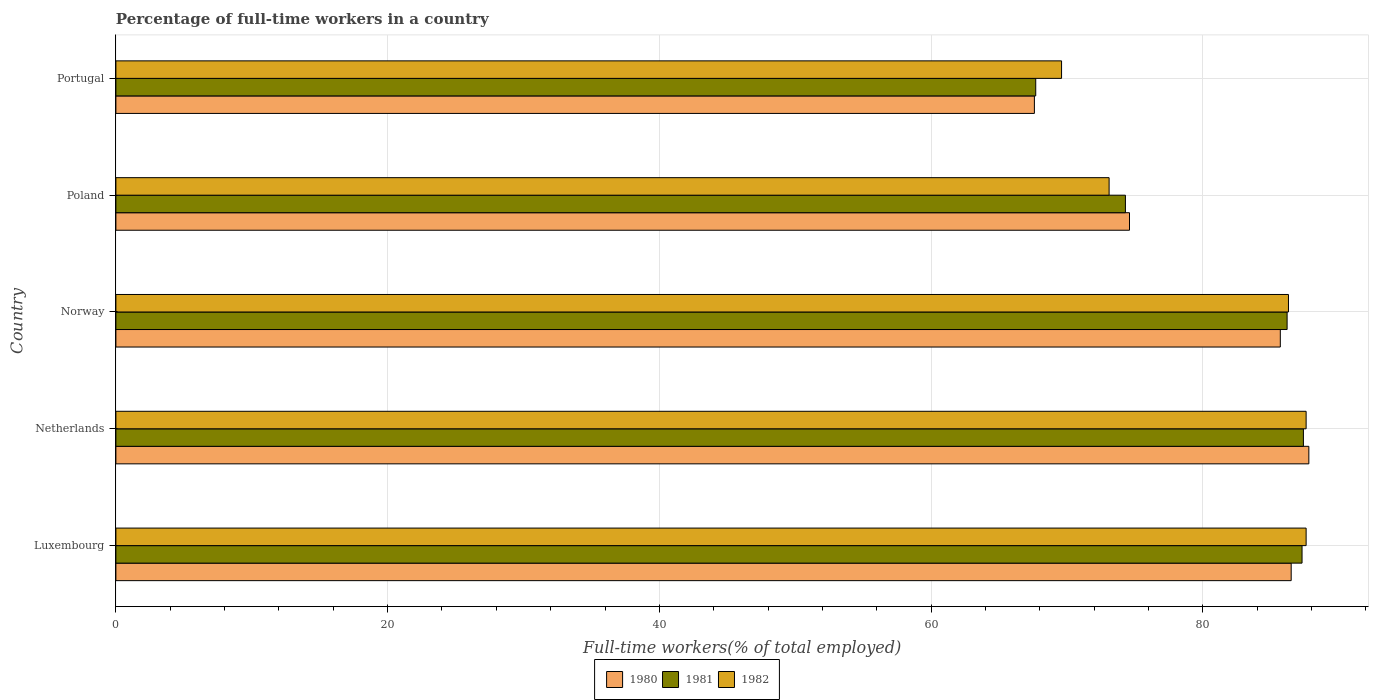Are the number of bars per tick equal to the number of legend labels?
Provide a succinct answer. Yes. Are the number of bars on each tick of the Y-axis equal?
Make the answer very short. Yes. What is the label of the 2nd group of bars from the top?
Offer a terse response. Poland. In how many cases, is the number of bars for a given country not equal to the number of legend labels?
Keep it short and to the point. 0. What is the percentage of full-time workers in 1980 in Netherlands?
Make the answer very short. 87.8. Across all countries, what is the maximum percentage of full-time workers in 1982?
Give a very brief answer. 87.6. Across all countries, what is the minimum percentage of full-time workers in 1980?
Make the answer very short. 67.6. In which country was the percentage of full-time workers in 1980 minimum?
Give a very brief answer. Portugal. What is the total percentage of full-time workers in 1980 in the graph?
Make the answer very short. 402.2. What is the difference between the percentage of full-time workers in 1981 in Poland and the percentage of full-time workers in 1980 in Portugal?
Provide a short and direct response. 6.7. What is the average percentage of full-time workers in 1980 per country?
Offer a very short reply. 80.44. What is the difference between the percentage of full-time workers in 1981 and percentage of full-time workers in 1980 in Poland?
Your answer should be very brief. -0.3. In how many countries, is the percentage of full-time workers in 1980 greater than 4 %?
Keep it short and to the point. 5. What is the ratio of the percentage of full-time workers in 1982 in Luxembourg to that in Poland?
Give a very brief answer. 1.2. Is the percentage of full-time workers in 1980 in Poland less than that in Portugal?
Provide a short and direct response. No. Is the difference between the percentage of full-time workers in 1981 in Poland and Portugal greater than the difference between the percentage of full-time workers in 1980 in Poland and Portugal?
Make the answer very short. No. What is the difference between the highest and the second highest percentage of full-time workers in 1980?
Ensure brevity in your answer.  1.3. What does the 2nd bar from the top in Luxembourg represents?
Your answer should be compact. 1981. Is it the case that in every country, the sum of the percentage of full-time workers in 1982 and percentage of full-time workers in 1980 is greater than the percentage of full-time workers in 1981?
Keep it short and to the point. Yes. Are the values on the major ticks of X-axis written in scientific E-notation?
Provide a short and direct response. No. How many legend labels are there?
Your response must be concise. 3. How are the legend labels stacked?
Ensure brevity in your answer.  Horizontal. What is the title of the graph?
Provide a succinct answer. Percentage of full-time workers in a country. Does "2008" appear as one of the legend labels in the graph?
Your answer should be compact. No. What is the label or title of the X-axis?
Give a very brief answer. Full-time workers(% of total employed). What is the label or title of the Y-axis?
Provide a short and direct response. Country. What is the Full-time workers(% of total employed) of 1980 in Luxembourg?
Ensure brevity in your answer.  86.5. What is the Full-time workers(% of total employed) of 1981 in Luxembourg?
Provide a short and direct response. 87.3. What is the Full-time workers(% of total employed) in 1982 in Luxembourg?
Keep it short and to the point. 87.6. What is the Full-time workers(% of total employed) in 1980 in Netherlands?
Offer a terse response. 87.8. What is the Full-time workers(% of total employed) of 1981 in Netherlands?
Ensure brevity in your answer.  87.4. What is the Full-time workers(% of total employed) in 1982 in Netherlands?
Make the answer very short. 87.6. What is the Full-time workers(% of total employed) of 1980 in Norway?
Give a very brief answer. 85.7. What is the Full-time workers(% of total employed) of 1981 in Norway?
Your response must be concise. 86.2. What is the Full-time workers(% of total employed) of 1982 in Norway?
Make the answer very short. 86.3. What is the Full-time workers(% of total employed) of 1980 in Poland?
Keep it short and to the point. 74.6. What is the Full-time workers(% of total employed) of 1981 in Poland?
Keep it short and to the point. 74.3. What is the Full-time workers(% of total employed) in 1982 in Poland?
Make the answer very short. 73.1. What is the Full-time workers(% of total employed) in 1980 in Portugal?
Your answer should be very brief. 67.6. What is the Full-time workers(% of total employed) of 1981 in Portugal?
Give a very brief answer. 67.7. What is the Full-time workers(% of total employed) in 1982 in Portugal?
Keep it short and to the point. 69.6. Across all countries, what is the maximum Full-time workers(% of total employed) in 1980?
Your answer should be very brief. 87.8. Across all countries, what is the maximum Full-time workers(% of total employed) in 1981?
Make the answer very short. 87.4. Across all countries, what is the maximum Full-time workers(% of total employed) in 1982?
Keep it short and to the point. 87.6. Across all countries, what is the minimum Full-time workers(% of total employed) in 1980?
Offer a very short reply. 67.6. Across all countries, what is the minimum Full-time workers(% of total employed) of 1981?
Offer a very short reply. 67.7. Across all countries, what is the minimum Full-time workers(% of total employed) of 1982?
Ensure brevity in your answer.  69.6. What is the total Full-time workers(% of total employed) in 1980 in the graph?
Provide a succinct answer. 402.2. What is the total Full-time workers(% of total employed) in 1981 in the graph?
Provide a short and direct response. 402.9. What is the total Full-time workers(% of total employed) in 1982 in the graph?
Provide a succinct answer. 404.2. What is the difference between the Full-time workers(% of total employed) of 1980 in Luxembourg and that in Netherlands?
Offer a very short reply. -1.3. What is the difference between the Full-time workers(% of total employed) in 1980 in Luxembourg and that in Norway?
Offer a very short reply. 0.8. What is the difference between the Full-time workers(% of total employed) in 1981 in Luxembourg and that in Norway?
Keep it short and to the point. 1.1. What is the difference between the Full-time workers(% of total employed) of 1980 in Luxembourg and that in Poland?
Your answer should be very brief. 11.9. What is the difference between the Full-time workers(% of total employed) of 1981 in Luxembourg and that in Poland?
Your answer should be very brief. 13. What is the difference between the Full-time workers(% of total employed) of 1981 in Luxembourg and that in Portugal?
Make the answer very short. 19.6. What is the difference between the Full-time workers(% of total employed) in 1980 in Netherlands and that in Norway?
Provide a short and direct response. 2.1. What is the difference between the Full-time workers(% of total employed) in 1982 in Netherlands and that in Norway?
Keep it short and to the point. 1.3. What is the difference between the Full-time workers(% of total employed) of 1980 in Netherlands and that in Portugal?
Ensure brevity in your answer.  20.2. What is the difference between the Full-time workers(% of total employed) of 1981 in Netherlands and that in Portugal?
Provide a succinct answer. 19.7. What is the difference between the Full-time workers(% of total employed) of 1980 in Norway and that in Poland?
Give a very brief answer. 11.1. What is the difference between the Full-time workers(% of total employed) in 1982 in Norway and that in Poland?
Offer a very short reply. 13.2. What is the difference between the Full-time workers(% of total employed) of 1981 in Norway and that in Portugal?
Ensure brevity in your answer.  18.5. What is the difference between the Full-time workers(% of total employed) in 1982 in Norway and that in Portugal?
Ensure brevity in your answer.  16.7. What is the difference between the Full-time workers(% of total employed) of 1981 in Poland and that in Portugal?
Give a very brief answer. 6.6. What is the difference between the Full-time workers(% of total employed) in 1982 in Poland and that in Portugal?
Offer a very short reply. 3.5. What is the difference between the Full-time workers(% of total employed) in 1980 in Luxembourg and the Full-time workers(% of total employed) in 1981 in Netherlands?
Offer a terse response. -0.9. What is the difference between the Full-time workers(% of total employed) in 1980 in Luxembourg and the Full-time workers(% of total employed) in 1982 in Netherlands?
Give a very brief answer. -1.1. What is the difference between the Full-time workers(% of total employed) of 1980 in Luxembourg and the Full-time workers(% of total employed) of 1982 in Norway?
Offer a terse response. 0.2. What is the difference between the Full-time workers(% of total employed) in 1980 in Luxembourg and the Full-time workers(% of total employed) in 1981 in Poland?
Provide a short and direct response. 12.2. What is the difference between the Full-time workers(% of total employed) in 1980 in Netherlands and the Full-time workers(% of total employed) in 1981 in Norway?
Offer a very short reply. 1.6. What is the difference between the Full-time workers(% of total employed) of 1981 in Netherlands and the Full-time workers(% of total employed) of 1982 in Norway?
Your answer should be compact. 1.1. What is the difference between the Full-time workers(% of total employed) in 1980 in Netherlands and the Full-time workers(% of total employed) in 1981 in Portugal?
Keep it short and to the point. 20.1. What is the difference between the Full-time workers(% of total employed) in 1980 in Norway and the Full-time workers(% of total employed) in 1981 in Poland?
Your answer should be compact. 11.4. What is the difference between the Full-time workers(% of total employed) in 1980 in Norway and the Full-time workers(% of total employed) in 1982 in Poland?
Provide a succinct answer. 12.6. What is the difference between the Full-time workers(% of total employed) in 1981 in Norway and the Full-time workers(% of total employed) in 1982 in Poland?
Give a very brief answer. 13.1. What is the difference between the Full-time workers(% of total employed) of 1980 in Norway and the Full-time workers(% of total employed) of 1981 in Portugal?
Offer a terse response. 18. What is the average Full-time workers(% of total employed) in 1980 per country?
Provide a succinct answer. 80.44. What is the average Full-time workers(% of total employed) of 1981 per country?
Your response must be concise. 80.58. What is the average Full-time workers(% of total employed) of 1982 per country?
Make the answer very short. 80.84. What is the difference between the Full-time workers(% of total employed) of 1980 and Full-time workers(% of total employed) of 1981 in Luxembourg?
Provide a succinct answer. -0.8. What is the difference between the Full-time workers(% of total employed) of 1980 and Full-time workers(% of total employed) of 1982 in Luxembourg?
Provide a succinct answer. -1.1. What is the difference between the Full-time workers(% of total employed) of 1980 and Full-time workers(% of total employed) of 1981 in Netherlands?
Offer a very short reply. 0.4. What is the difference between the Full-time workers(% of total employed) of 1980 and Full-time workers(% of total employed) of 1982 in Norway?
Give a very brief answer. -0.6. What is the difference between the Full-time workers(% of total employed) of 1980 and Full-time workers(% of total employed) of 1982 in Poland?
Your response must be concise. 1.5. What is the difference between the Full-time workers(% of total employed) of 1981 and Full-time workers(% of total employed) of 1982 in Portugal?
Keep it short and to the point. -1.9. What is the ratio of the Full-time workers(% of total employed) of 1980 in Luxembourg to that in Netherlands?
Your answer should be very brief. 0.99. What is the ratio of the Full-time workers(% of total employed) of 1981 in Luxembourg to that in Netherlands?
Your answer should be compact. 1. What is the ratio of the Full-time workers(% of total employed) of 1982 in Luxembourg to that in Netherlands?
Provide a succinct answer. 1. What is the ratio of the Full-time workers(% of total employed) of 1980 in Luxembourg to that in Norway?
Keep it short and to the point. 1.01. What is the ratio of the Full-time workers(% of total employed) in 1981 in Luxembourg to that in Norway?
Give a very brief answer. 1.01. What is the ratio of the Full-time workers(% of total employed) in 1982 in Luxembourg to that in Norway?
Provide a succinct answer. 1.02. What is the ratio of the Full-time workers(% of total employed) in 1980 in Luxembourg to that in Poland?
Make the answer very short. 1.16. What is the ratio of the Full-time workers(% of total employed) of 1981 in Luxembourg to that in Poland?
Give a very brief answer. 1.18. What is the ratio of the Full-time workers(% of total employed) in 1982 in Luxembourg to that in Poland?
Provide a succinct answer. 1.2. What is the ratio of the Full-time workers(% of total employed) in 1980 in Luxembourg to that in Portugal?
Your answer should be compact. 1.28. What is the ratio of the Full-time workers(% of total employed) of 1981 in Luxembourg to that in Portugal?
Provide a short and direct response. 1.29. What is the ratio of the Full-time workers(% of total employed) in 1982 in Luxembourg to that in Portugal?
Give a very brief answer. 1.26. What is the ratio of the Full-time workers(% of total employed) of 1980 in Netherlands to that in Norway?
Provide a short and direct response. 1.02. What is the ratio of the Full-time workers(% of total employed) of 1981 in Netherlands to that in Norway?
Your response must be concise. 1.01. What is the ratio of the Full-time workers(% of total employed) of 1982 in Netherlands to that in Norway?
Your response must be concise. 1.02. What is the ratio of the Full-time workers(% of total employed) in 1980 in Netherlands to that in Poland?
Provide a short and direct response. 1.18. What is the ratio of the Full-time workers(% of total employed) in 1981 in Netherlands to that in Poland?
Offer a very short reply. 1.18. What is the ratio of the Full-time workers(% of total employed) of 1982 in Netherlands to that in Poland?
Provide a short and direct response. 1.2. What is the ratio of the Full-time workers(% of total employed) of 1980 in Netherlands to that in Portugal?
Provide a short and direct response. 1.3. What is the ratio of the Full-time workers(% of total employed) of 1981 in Netherlands to that in Portugal?
Ensure brevity in your answer.  1.29. What is the ratio of the Full-time workers(% of total employed) in 1982 in Netherlands to that in Portugal?
Keep it short and to the point. 1.26. What is the ratio of the Full-time workers(% of total employed) in 1980 in Norway to that in Poland?
Provide a succinct answer. 1.15. What is the ratio of the Full-time workers(% of total employed) of 1981 in Norway to that in Poland?
Your response must be concise. 1.16. What is the ratio of the Full-time workers(% of total employed) of 1982 in Norway to that in Poland?
Your answer should be very brief. 1.18. What is the ratio of the Full-time workers(% of total employed) in 1980 in Norway to that in Portugal?
Your response must be concise. 1.27. What is the ratio of the Full-time workers(% of total employed) of 1981 in Norway to that in Portugal?
Provide a succinct answer. 1.27. What is the ratio of the Full-time workers(% of total employed) of 1982 in Norway to that in Portugal?
Keep it short and to the point. 1.24. What is the ratio of the Full-time workers(% of total employed) in 1980 in Poland to that in Portugal?
Your response must be concise. 1.1. What is the ratio of the Full-time workers(% of total employed) in 1981 in Poland to that in Portugal?
Offer a terse response. 1.1. What is the ratio of the Full-time workers(% of total employed) in 1982 in Poland to that in Portugal?
Your answer should be very brief. 1.05. What is the difference between the highest and the second highest Full-time workers(% of total employed) of 1980?
Your response must be concise. 1.3. What is the difference between the highest and the second highest Full-time workers(% of total employed) in 1981?
Your response must be concise. 0.1. What is the difference between the highest and the lowest Full-time workers(% of total employed) of 1980?
Offer a terse response. 20.2. What is the difference between the highest and the lowest Full-time workers(% of total employed) in 1982?
Provide a succinct answer. 18. 